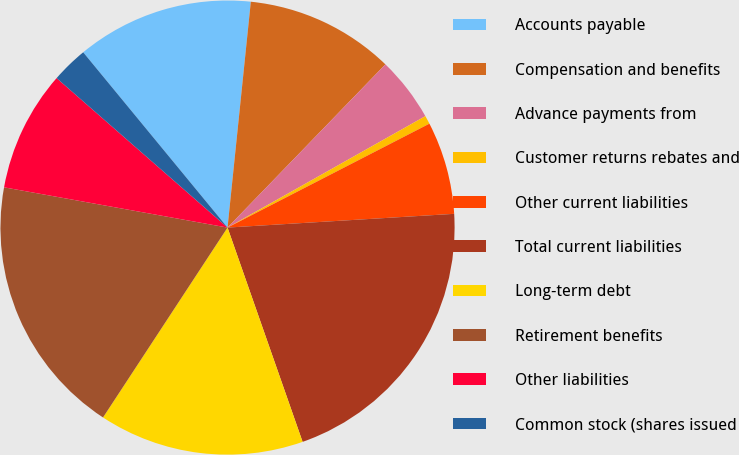<chart> <loc_0><loc_0><loc_500><loc_500><pie_chart><fcel>Accounts payable<fcel>Compensation and benefits<fcel>Advance payments from<fcel>Customer returns rebates and<fcel>Other current liabilities<fcel>Total current liabilities<fcel>Long-term debt<fcel>Retirement benefits<fcel>Other liabilities<fcel>Common stock (shares issued<nl><fcel>12.6%<fcel>10.6%<fcel>4.6%<fcel>0.6%<fcel>6.6%<fcel>20.6%<fcel>14.6%<fcel>18.6%<fcel>8.6%<fcel>2.6%<nl></chart> 